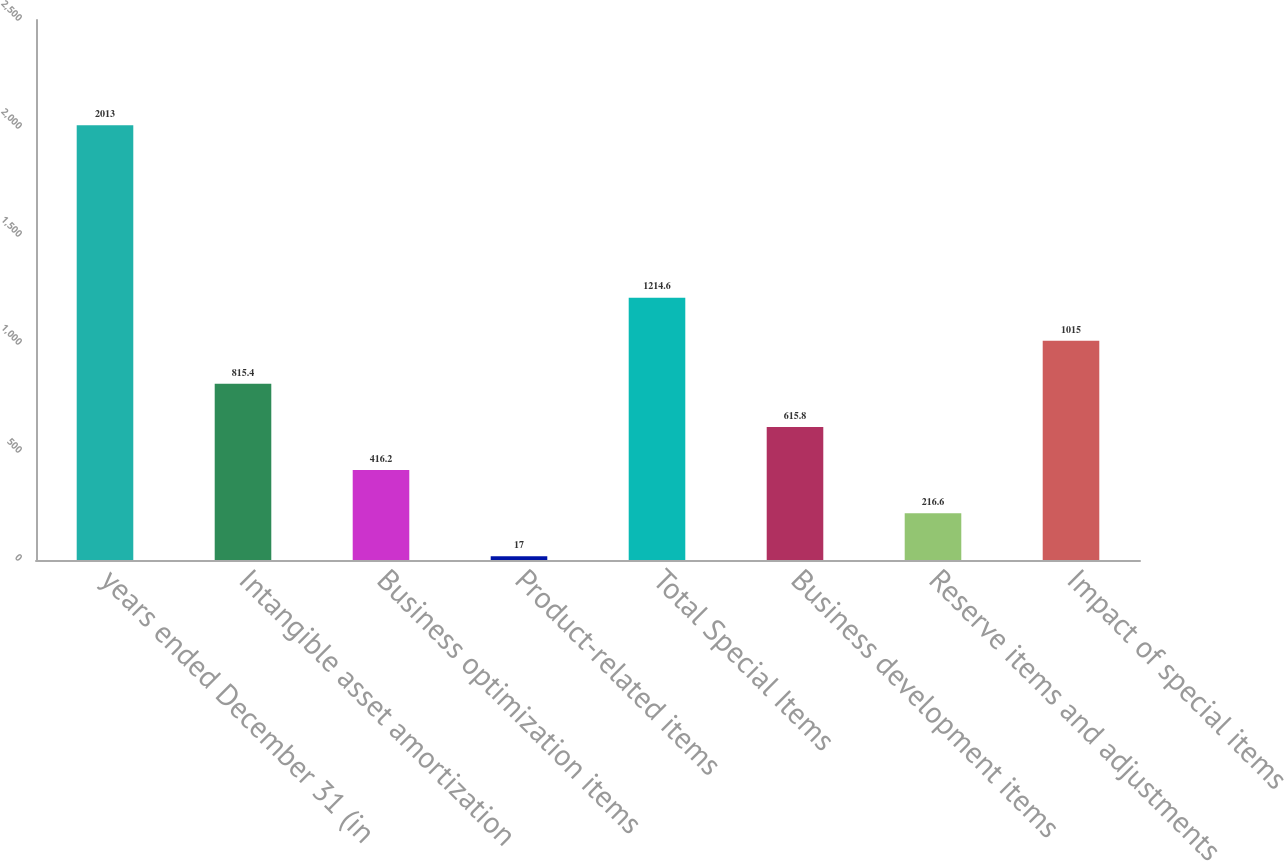<chart> <loc_0><loc_0><loc_500><loc_500><bar_chart><fcel>years ended December 31 (in<fcel>Intangible asset amortization<fcel>Business optimization items<fcel>Product-related items<fcel>Total Special Items<fcel>Business development items<fcel>Reserve items and adjustments<fcel>Impact of special items<nl><fcel>2013<fcel>815.4<fcel>416.2<fcel>17<fcel>1214.6<fcel>615.8<fcel>216.6<fcel>1015<nl></chart> 